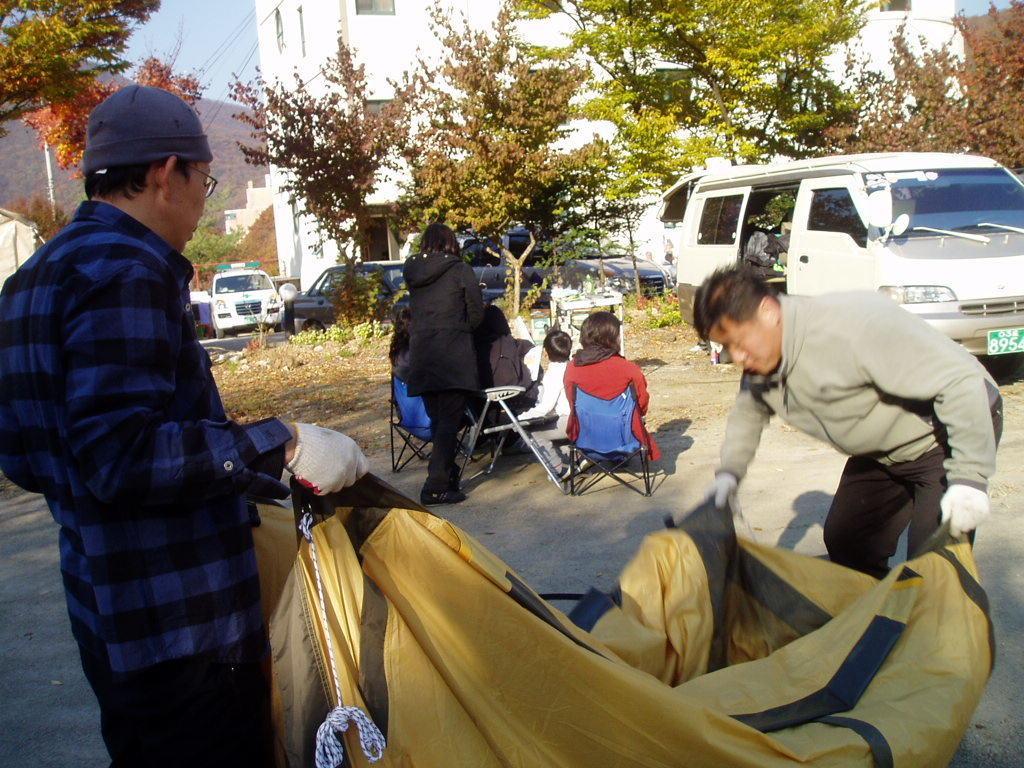Please provide a concise description of this image. In this picture, we can see a few people sitting, a few are standing and a few are holding some objects, and we can see the ground, chairs, a few vehicles, poles, wires, trees, mountain, building, and the sky. 